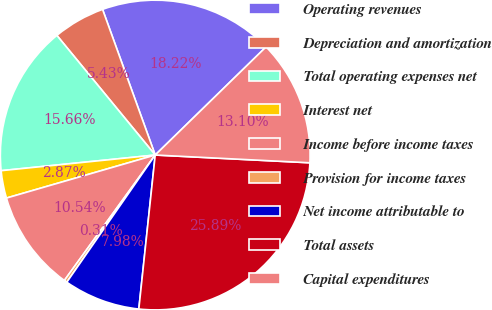<chart> <loc_0><loc_0><loc_500><loc_500><pie_chart><fcel>Operating revenues<fcel>Depreciation and amortization<fcel>Total operating expenses net<fcel>Interest net<fcel>Income before income taxes<fcel>Provision for income taxes<fcel>Net income attributable to<fcel>Total assets<fcel>Capital expenditures<nl><fcel>18.22%<fcel>5.43%<fcel>15.66%<fcel>2.87%<fcel>10.54%<fcel>0.31%<fcel>7.98%<fcel>25.89%<fcel>13.1%<nl></chart> 